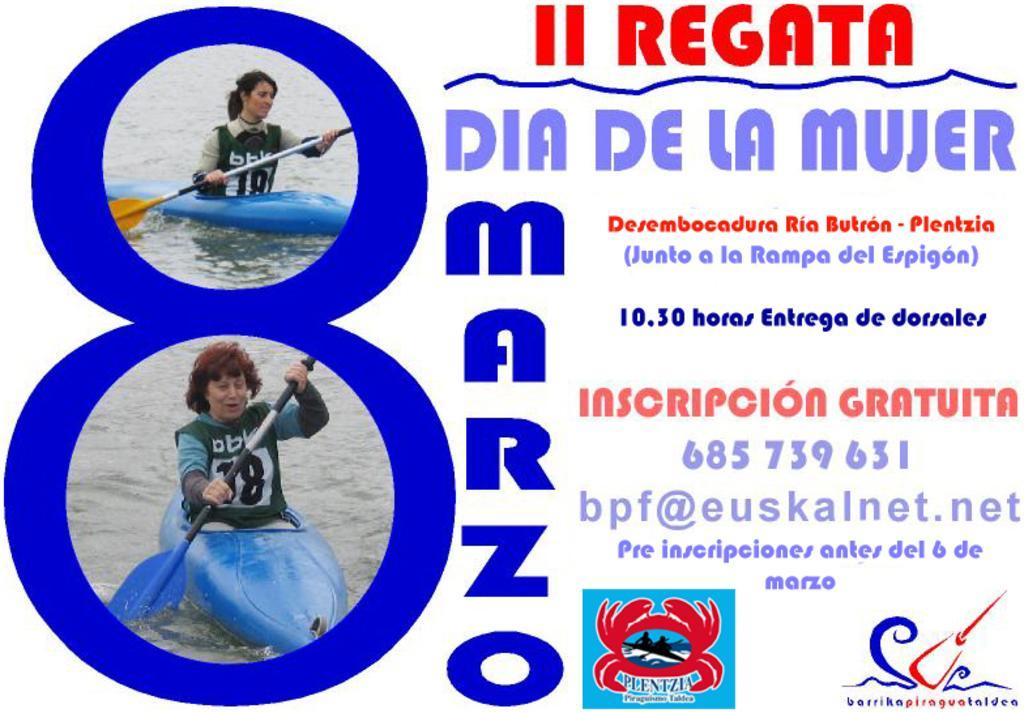Could you give a brief overview of what you see in this image? In this image we can see a poster. There is some text, logos and few persons rowing a water crafts in the image. 